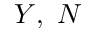Convert formula to latex. <formula><loc_0><loc_0><loc_500><loc_500>Y , N</formula> 